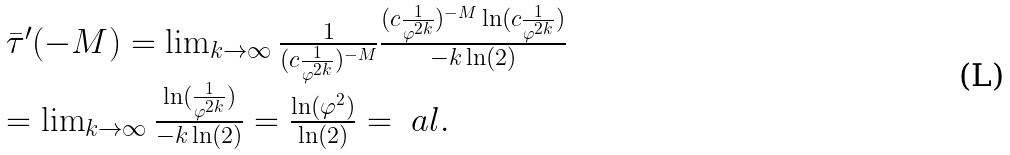<formula> <loc_0><loc_0><loc_500><loc_500>\begin{array} { l c l } \bar { \tau } ^ { \prime } ( - M ) = \lim _ { k \to \infty } \frac { 1 } { ( c \frac { 1 } { \varphi ^ { 2 k } } ) ^ { - M } } \frac { ( c \frac { 1 } { \varphi ^ { 2 k } } ) ^ { - M } \ln ( c \frac { 1 } { \varphi ^ { 2 k } } ) } { - k \ln ( 2 ) } \\ = \lim _ { k \to \infty } \frac { \ln ( \frac { 1 } { \varphi ^ { 2 k } } ) } { - k \ln ( 2 ) } = \frac { \ln ( \varphi ^ { 2 } ) } { \ln ( 2 ) } = \ a l . \end{array}</formula> 